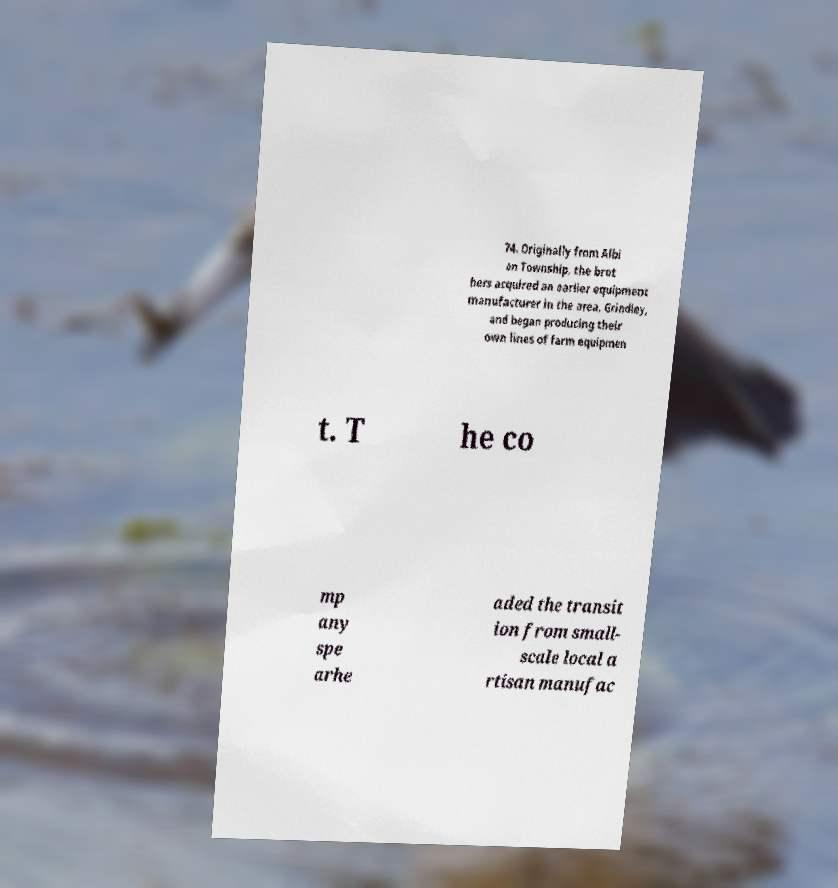There's text embedded in this image that I need extracted. Can you transcribe it verbatim? 74. Originally from Albi on Township, the brot hers acquired an earlier equipment manufacturer in the area, Grindley, and began producing their own lines of farm equipmen t. T he co mp any spe arhe aded the transit ion from small- scale local a rtisan manufac 